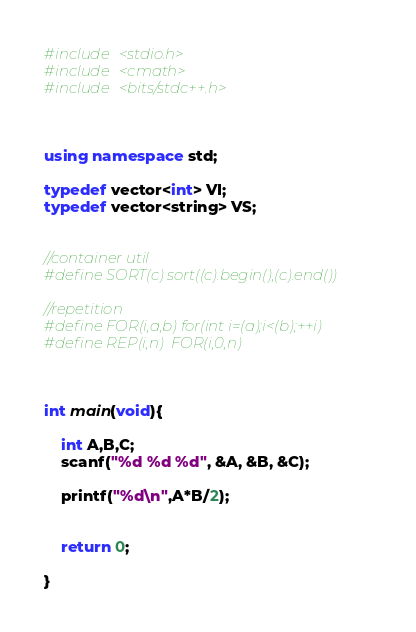<code> <loc_0><loc_0><loc_500><loc_500><_C++_>#include <stdio.h>
#include <cmath>
#include <bits/stdc++.h>



using namespace std;

typedef vector<int> VI;
typedef vector<string> VS;


//container util
#define SORT(c) sort((c).begin(),(c).end())

//repetition
#define FOR(i,a,b) for(int i=(a);i<(b);++i)
#define REP(i,n)  FOR(i,0,n)



int main(void){

	int A,B,C;
	scanf("%d %d %d", &A, &B, &C);

	printf("%d\n",A*B/2);


	return 0;

}
</code> 